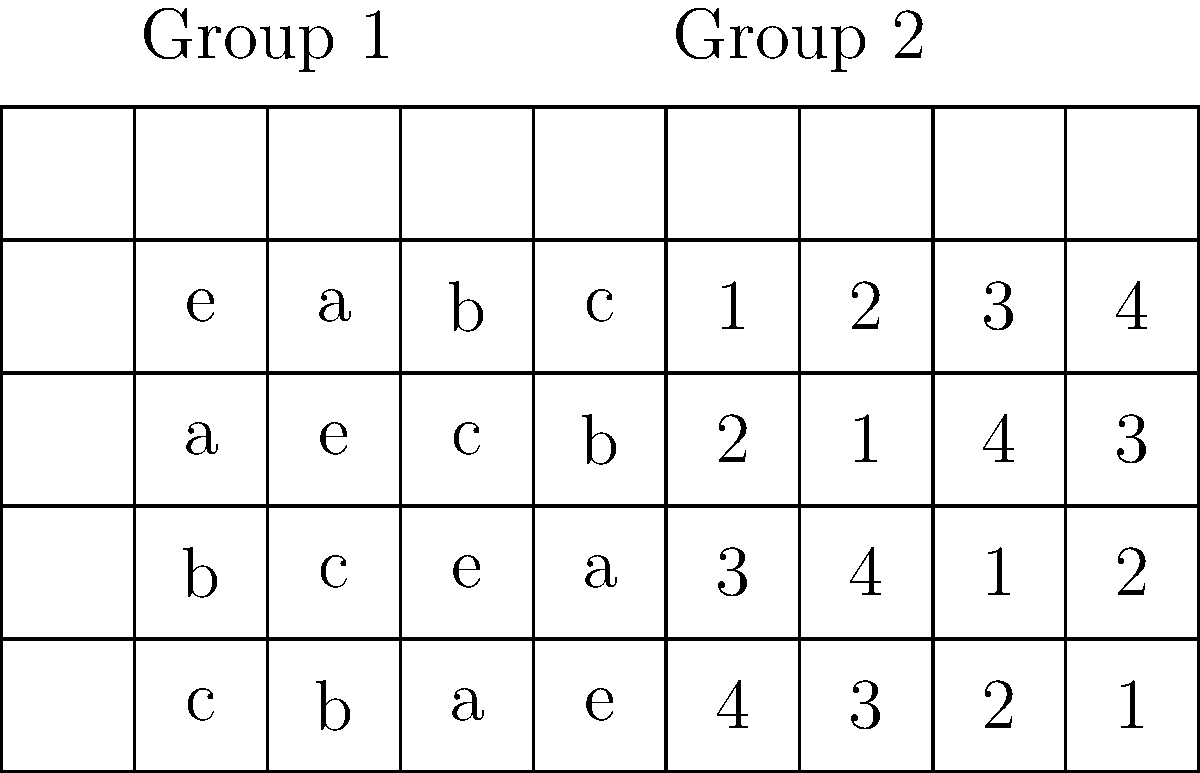Consider the Cayley tables for two groups of order 4 shown above. Are these groups isomorphic? Justify your answer. To determine if the groups are isomorphic, we need to follow these steps:

1. Check if the groups have the same order:
   Both groups have order 4, so this condition is satisfied.

2. Identify the identity elements:
   For Group 1, the identity is "e".
   For Group 2, the identity is "1".

3. Count the number of elements of each order:
   In Group 1:
   - "e" has order 1
   - "a", "b", and "c" have order 2 (they are their own inverses)
   
   In Group 2:
   - "1" has order 1
   - "2", "3", and "4" have order 2 (they are their own inverses)

4. Compare the structure:
   Both groups have one element of order 1 and three elements of order 2.
   The multiplication tables have the same structure, just with different labels.

5. Construct an isomorphism:
   We can define a bijection $\phi$ between the groups:
   $\phi(e) = 1$
   $\phi(a) = 2$
   $\phi(b) = 3$
   $\phi(c) = 4$

   This mapping preserves the group operation. For example:
   $\phi(a * b) = \phi(c) = 4 = 2 * 3 = \phi(a) * \phi(b)$

Since we have found an isomorphism between the groups, they are indeed isomorphic.
Answer: Yes, the groups are isomorphic. 